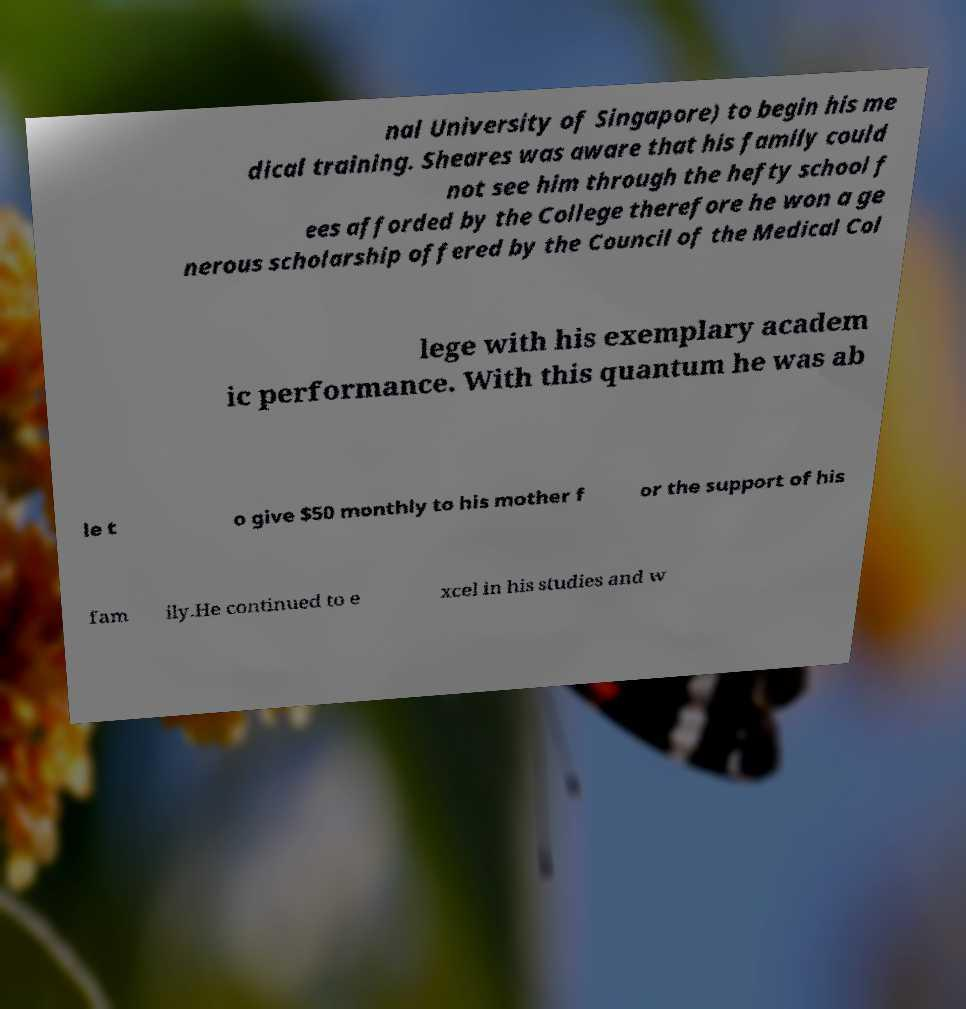There's text embedded in this image that I need extracted. Can you transcribe it verbatim? nal University of Singapore) to begin his me dical training. Sheares was aware that his family could not see him through the hefty school f ees afforded by the College therefore he won a ge nerous scholarship offered by the Council of the Medical Col lege with his exemplary academ ic performance. With this quantum he was ab le t o give $50 monthly to his mother f or the support of his fam ily.He continued to e xcel in his studies and w 